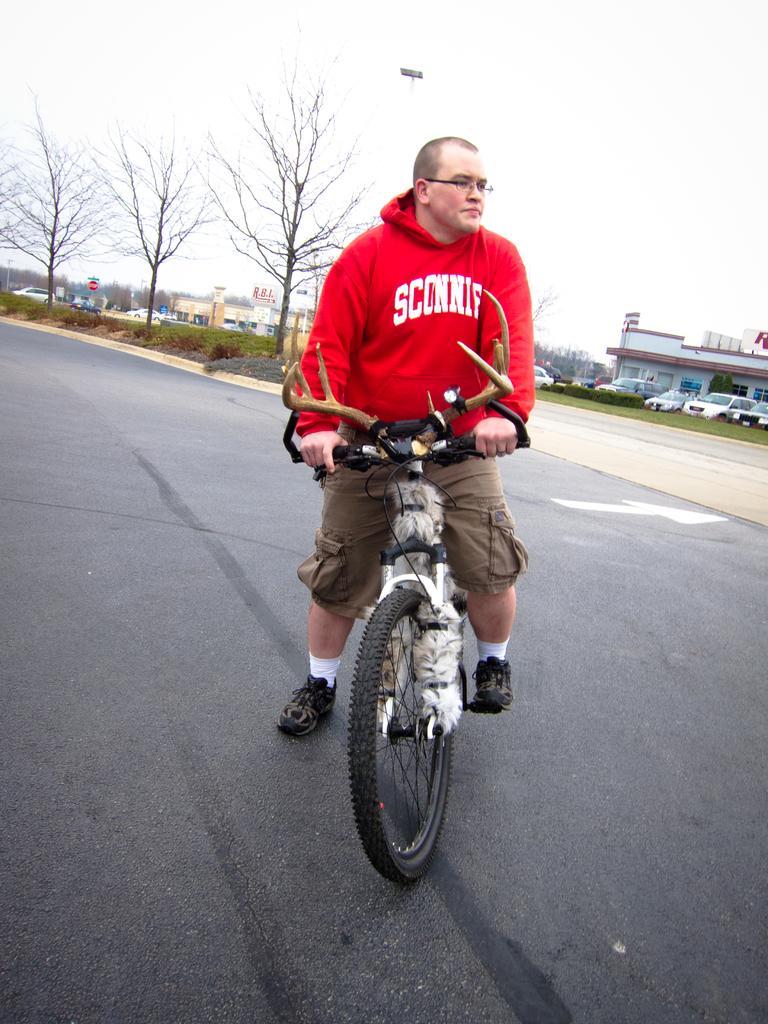How would you summarize this image in a sentence or two? In this image I can a man riding the bicycle on the road. In the background I can see a building, cars and the trees. 